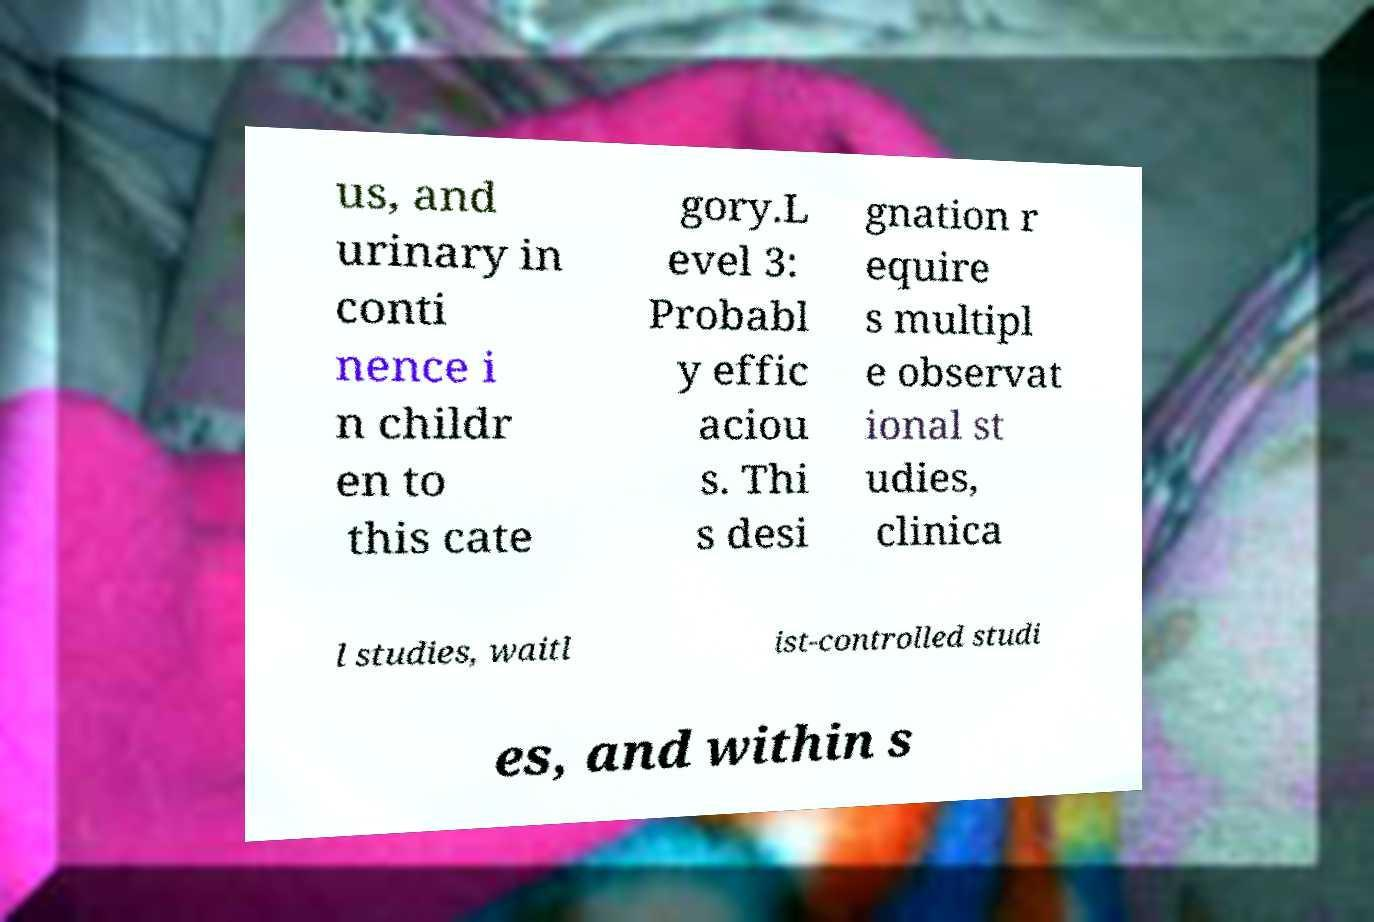Please read and relay the text visible in this image. What does it say? us, and urinary in conti nence i n childr en to this cate gory.L evel 3: Probabl y effic aciou s. Thi s desi gnation r equire s multipl e observat ional st udies, clinica l studies, waitl ist-controlled studi es, and within s 